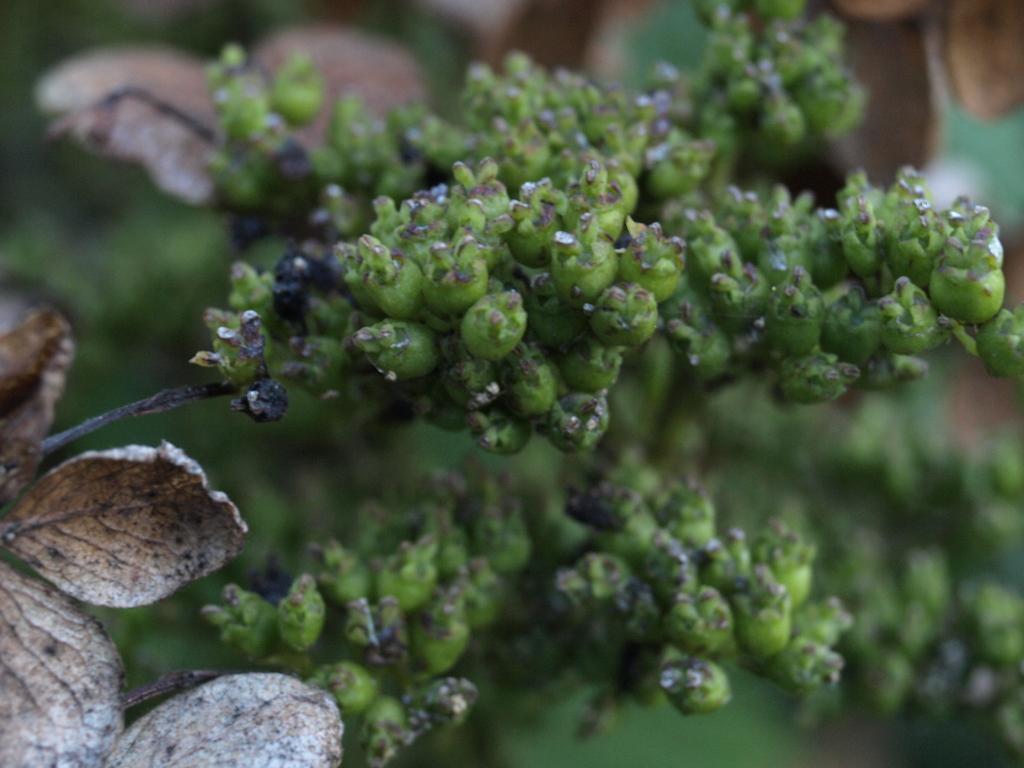Describe this image in one or two sentences. In this picture, we see plants. On the left side, we see dried leaves. In the background, it is green in color and it is blurred in the background. 